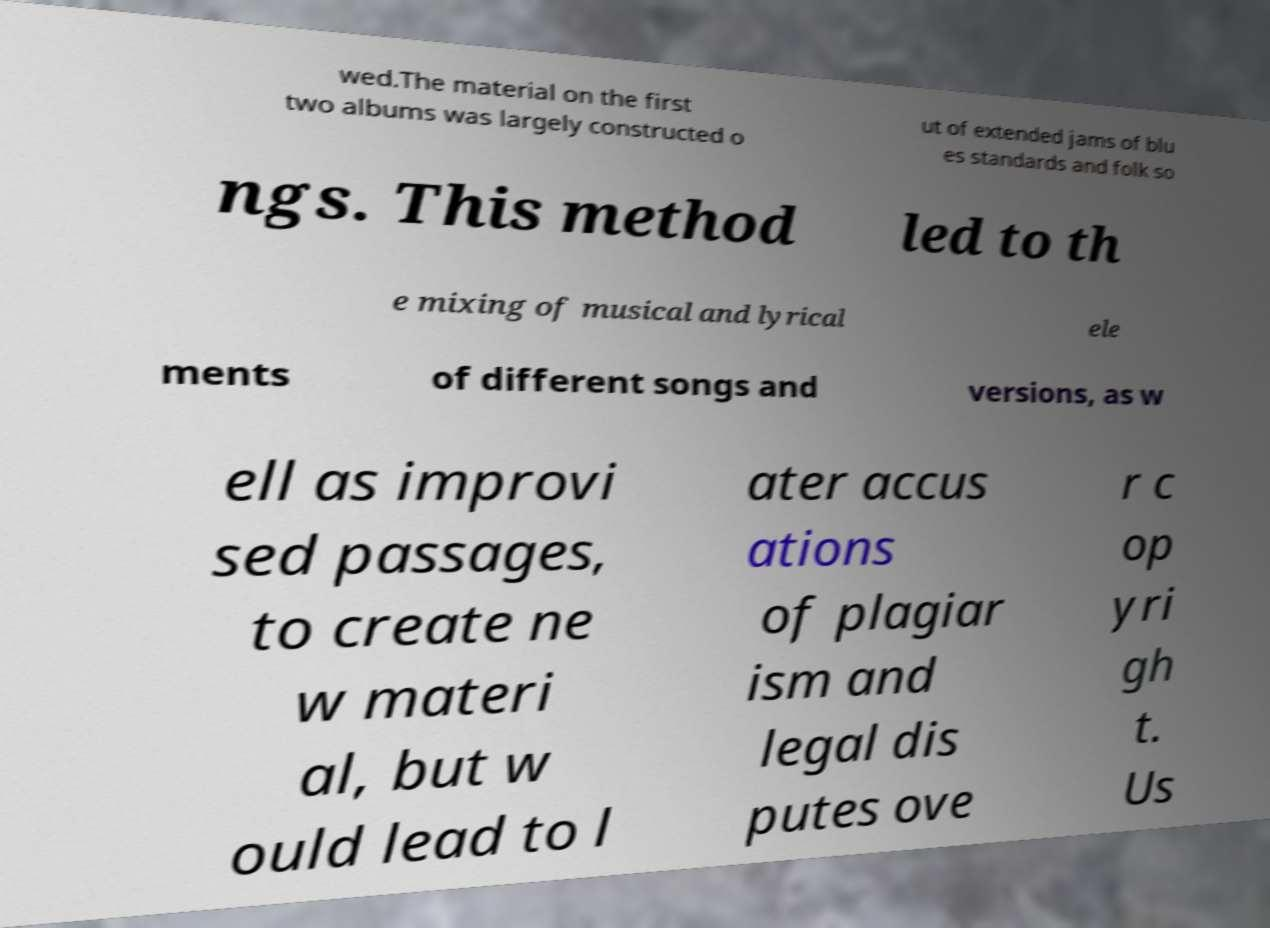I need the written content from this picture converted into text. Can you do that? wed.The material on the first two albums was largely constructed o ut of extended jams of blu es standards and folk so ngs. This method led to th e mixing of musical and lyrical ele ments of different songs and versions, as w ell as improvi sed passages, to create ne w materi al, but w ould lead to l ater accus ations of plagiar ism and legal dis putes ove r c op yri gh t. Us 